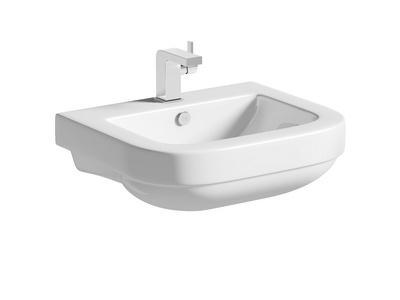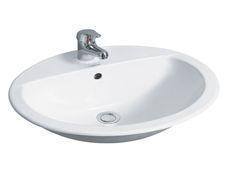The first image is the image on the left, the second image is the image on the right. Analyze the images presented: Is the assertion "The sink in one image has a soap dispenser." valid? Answer yes or no. No. The first image is the image on the left, the second image is the image on the right. For the images shown, is this caption "There is a square white sink with single faucet on top and cabinet underneath." true? Answer yes or no. No. 